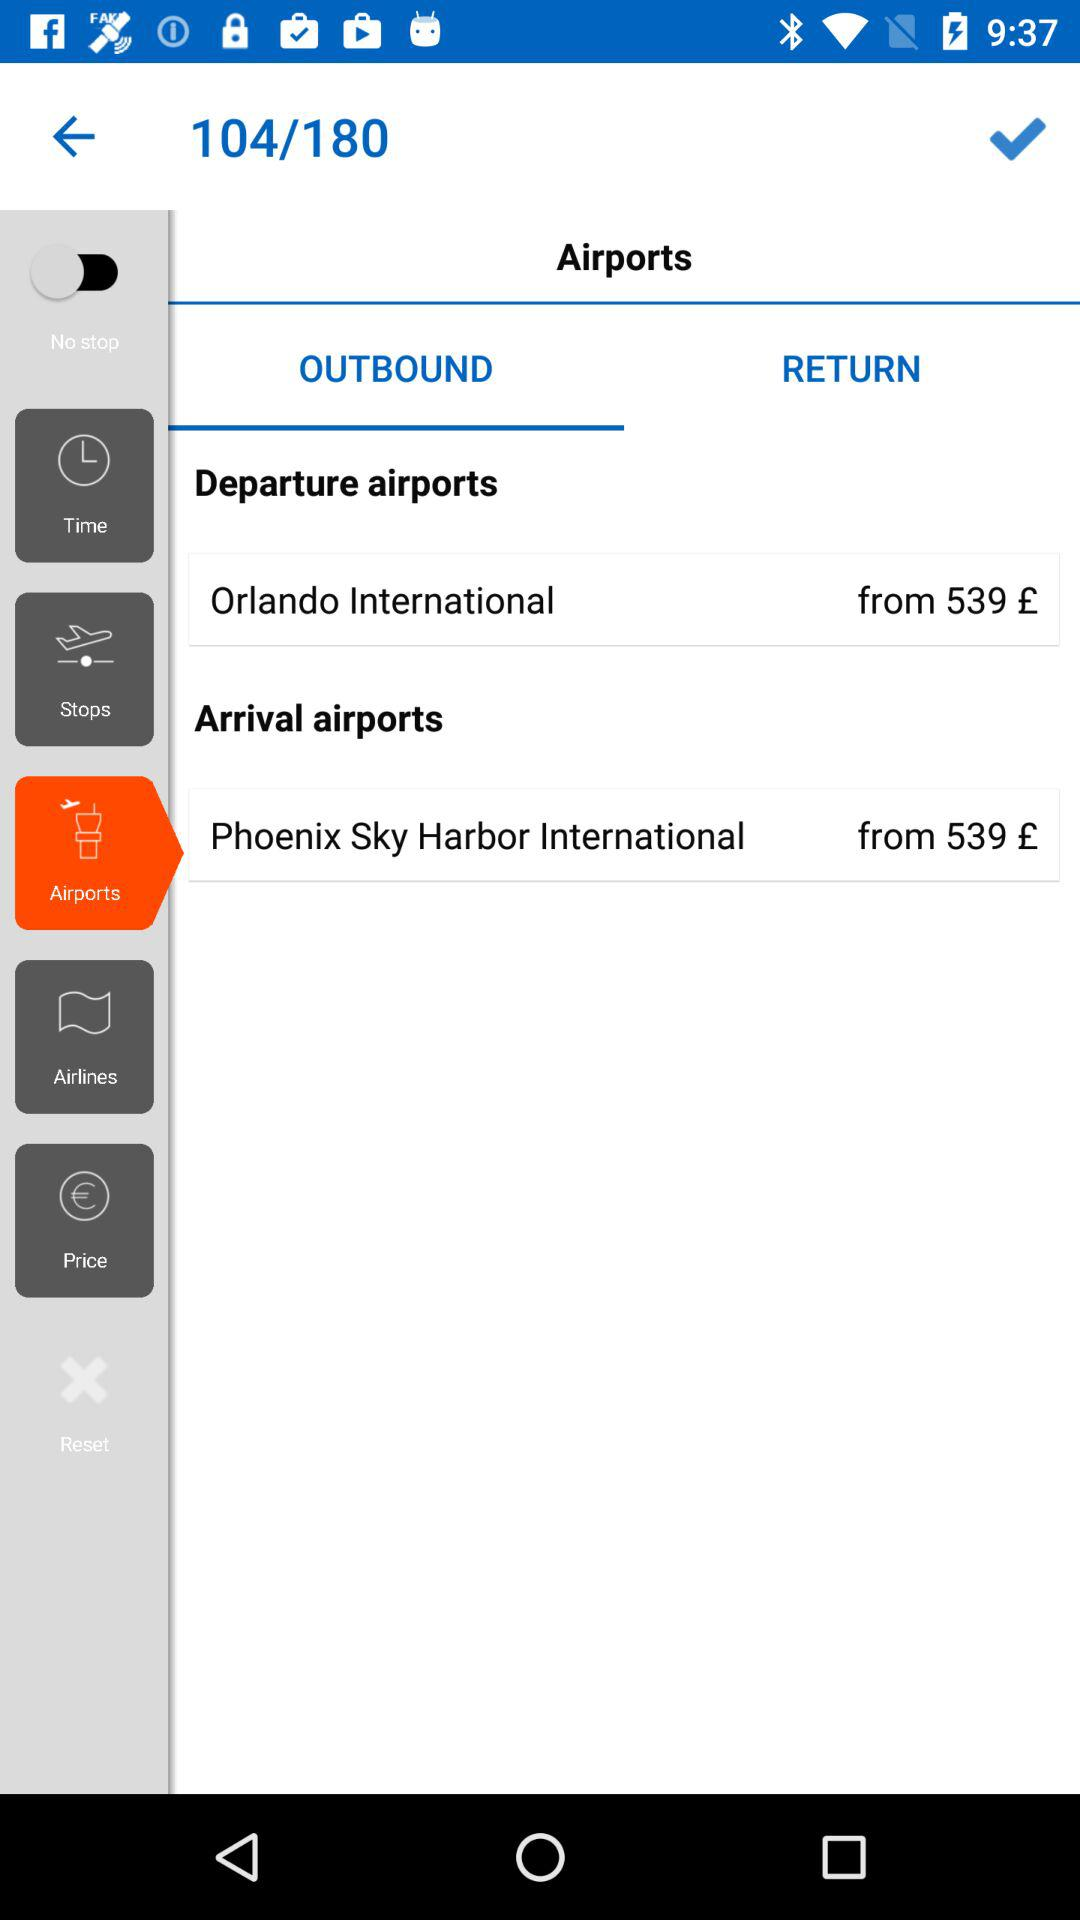What is the name of the arrival airport? The name of the arrival airport is "Phoenix Sky Harbor International". 